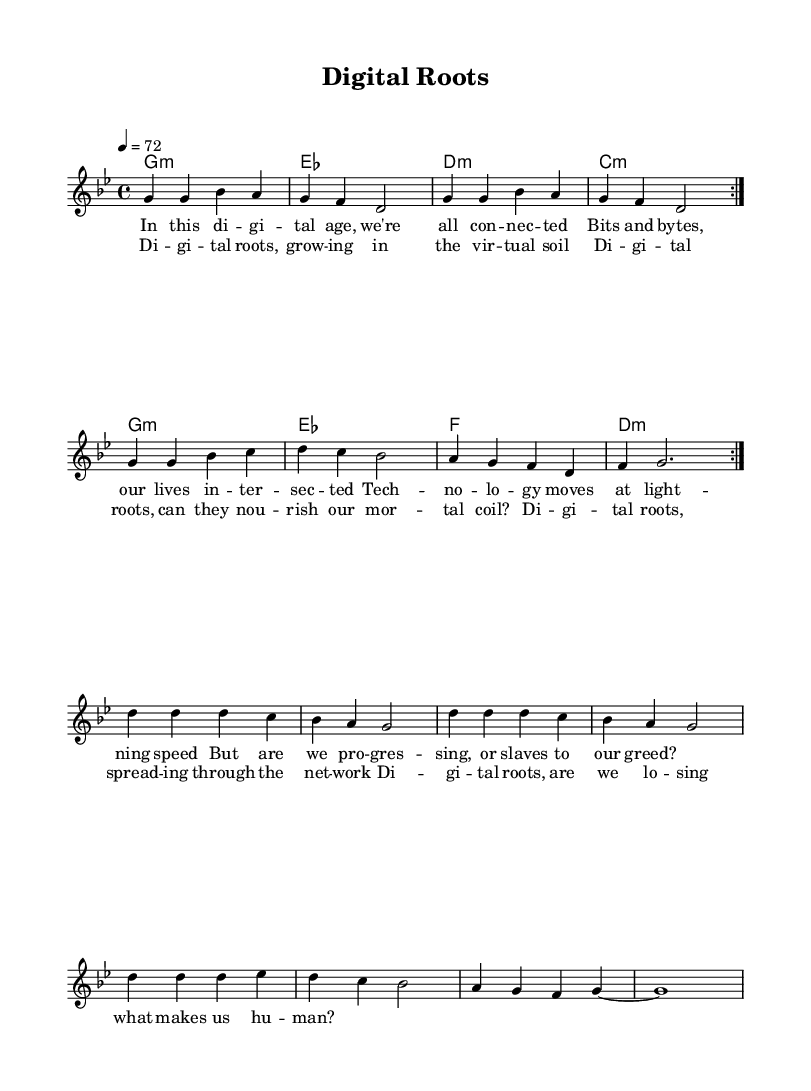What is the key signature of this music? The key signature indicated in the music is G minor, which has two flats. This can be identified by looking at the key signature section where the number of flats is depicted.
Answer: G minor What is the time signature of this music? The time signature is 4/4, which means there are four beats per measure. This is clearly shown at the beginning of the score where the time signature appears.
Answer: 4/4 What is the tempo marking for this piece? The tempo marking is quarter note equals 72 BPM. This is indicated at the beginning of the score, where the tempo is specified in beats per minute.
Answer: 72 How many distinct verses are in the lyrics section? There are two distinct sections in the lyrics: the verse and the chorus. The verse is followed by a chorus, and this structure is noted in the lyrics formatting.
Answer: 2 What theme do the lyrics of this song primarily explore? The lyrics explore themes of technology and its impact on humanity, as suggested by phrases like "digital age" and questioning whether technology is leading to progress or greed. This is evident from the lyrical content discussing technology's role in our lives.
Answer: Technology How many times is the repeat structure used in the melody? The melody includes a repeat structure that occurs twice at the beginning, indicated by the repeat signs. After that, a break occurs before continuing, which is all formatted based on repetition indication in the sheet music.
Answer: 2 